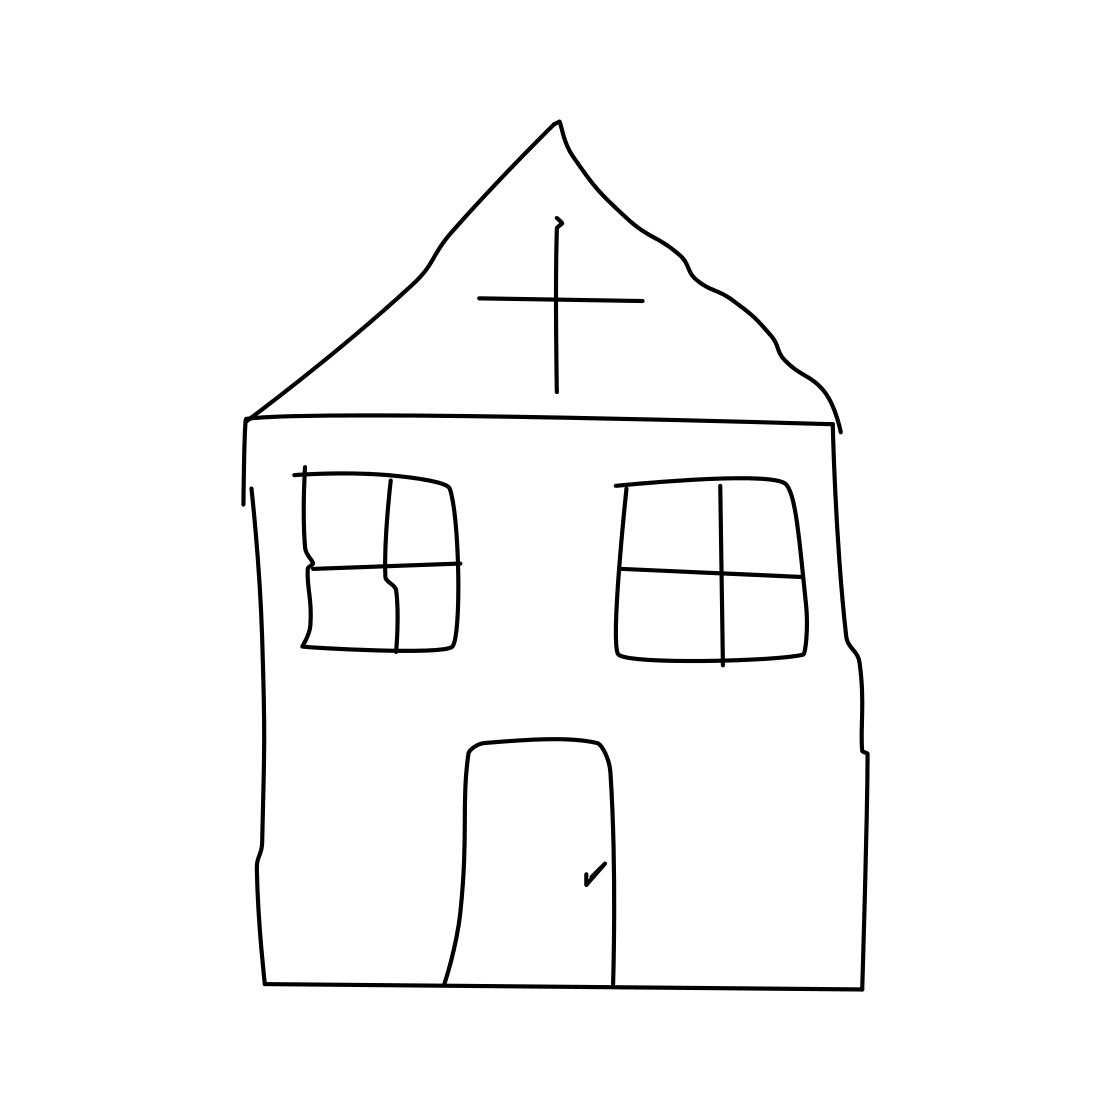Is there a sketchy church in the picture? Yes, the image features a hand-drawn representation of a church. Its simplistic and abstract style gives it a unique, sketchy appearance, characterized by the sharp-peaked roof and the cross at the top, typical symbols of a church. 